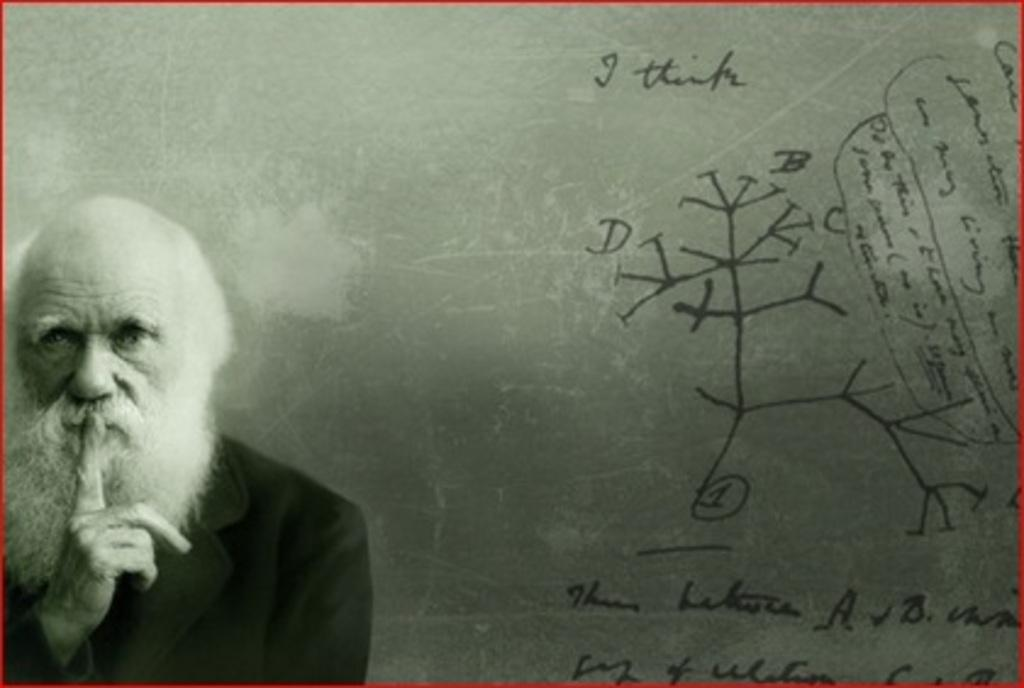What is the main subject of the image? There is a man standing in the image. What else can be seen on the right side of the image? There is text on the right side of the image. Can you describe the background of the image? There appears to be a board at the back of the image. How many ducks are present on the quilt in the image? There is no quilt or ducks present in the image. 